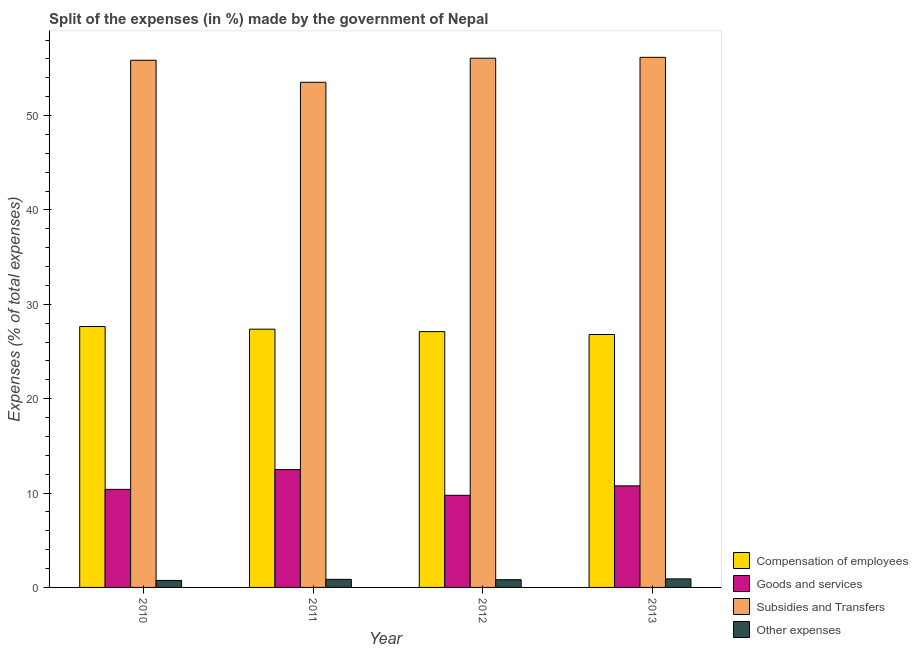Are the number of bars per tick equal to the number of legend labels?
Provide a short and direct response. Yes. Are the number of bars on each tick of the X-axis equal?
Your answer should be compact. Yes. How many bars are there on the 1st tick from the left?
Give a very brief answer. 4. How many bars are there on the 4th tick from the right?
Give a very brief answer. 4. In how many cases, is the number of bars for a given year not equal to the number of legend labels?
Provide a short and direct response. 0. What is the percentage of amount spent on goods and services in 2010?
Provide a short and direct response. 10.39. Across all years, what is the maximum percentage of amount spent on compensation of employees?
Your answer should be compact. 27.65. Across all years, what is the minimum percentage of amount spent on other expenses?
Make the answer very short. 0.74. In which year was the percentage of amount spent on other expenses minimum?
Make the answer very short. 2010. What is the total percentage of amount spent on goods and services in the graph?
Keep it short and to the point. 43.4. What is the difference between the percentage of amount spent on goods and services in 2011 and that in 2012?
Make the answer very short. 2.73. What is the difference between the percentage of amount spent on compensation of employees in 2013 and the percentage of amount spent on subsidies in 2010?
Provide a succinct answer. -0.84. What is the average percentage of amount spent on other expenses per year?
Offer a very short reply. 0.83. In the year 2012, what is the difference between the percentage of amount spent on subsidies and percentage of amount spent on other expenses?
Make the answer very short. 0. What is the ratio of the percentage of amount spent on subsidies in 2011 to that in 2012?
Offer a terse response. 0.95. Is the percentage of amount spent on compensation of employees in 2012 less than that in 2013?
Offer a very short reply. No. Is the difference between the percentage of amount spent on compensation of employees in 2011 and 2013 greater than the difference between the percentage of amount spent on subsidies in 2011 and 2013?
Provide a succinct answer. No. What is the difference between the highest and the second highest percentage of amount spent on subsidies?
Your response must be concise. 0.09. What is the difference between the highest and the lowest percentage of amount spent on subsidies?
Your answer should be very brief. 2.64. Is the sum of the percentage of amount spent on compensation of employees in 2010 and 2013 greater than the maximum percentage of amount spent on other expenses across all years?
Provide a succinct answer. Yes. Is it the case that in every year, the sum of the percentage of amount spent on compensation of employees and percentage of amount spent on other expenses is greater than the sum of percentage of amount spent on subsidies and percentage of amount spent on goods and services?
Keep it short and to the point. No. What does the 2nd bar from the left in 2013 represents?
Offer a very short reply. Goods and services. What does the 2nd bar from the right in 2012 represents?
Your answer should be compact. Subsidies and Transfers. Are all the bars in the graph horizontal?
Ensure brevity in your answer.  No. Are the values on the major ticks of Y-axis written in scientific E-notation?
Offer a terse response. No. Does the graph contain any zero values?
Provide a succinct answer. No. How many legend labels are there?
Give a very brief answer. 4. What is the title of the graph?
Ensure brevity in your answer.  Split of the expenses (in %) made by the government of Nepal. What is the label or title of the X-axis?
Ensure brevity in your answer.  Year. What is the label or title of the Y-axis?
Give a very brief answer. Expenses (% of total expenses). What is the Expenses (% of total expenses) of Compensation of employees in 2010?
Keep it short and to the point. 27.65. What is the Expenses (% of total expenses) in Goods and services in 2010?
Keep it short and to the point. 10.39. What is the Expenses (% of total expenses) of Subsidies and Transfers in 2010?
Ensure brevity in your answer.  55.87. What is the Expenses (% of total expenses) in Other expenses in 2010?
Give a very brief answer. 0.74. What is the Expenses (% of total expenses) in Compensation of employees in 2011?
Your answer should be very brief. 27.37. What is the Expenses (% of total expenses) in Goods and services in 2011?
Provide a succinct answer. 12.49. What is the Expenses (% of total expenses) in Subsidies and Transfers in 2011?
Offer a very short reply. 53.53. What is the Expenses (% of total expenses) of Other expenses in 2011?
Your response must be concise. 0.86. What is the Expenses (% of total expenses) in Compensation of employees in 2012?
Your response must be concise. 27.11. What is the Expenses (% of total expenses) in Goods and services in 2012?
Make the answer very short. 9.76. What is the Expenses (% of total expenses) in Subsidies and Transfers in 2012?
Your response must be concise. 56.08. What is the Expenses (% of total expenses) in Other expenses in 2012?
Ensure brevity in your answer.  0.82. What is the Expenses (% of total expenses) in Compensation of employees in 2013?
Your response must be concise. 26.8. What is the Expenses (% of total expenses) of Goods and services in 2013?
Offer a terse response. 10.76. What is the Expenses (% of total expenses) of Subsidies and Transfers in 2013?
Your response must be concise. 56.17. What is the Expenses (% of total expenses) of Other expenses in 2013?
Give a very brief answer. 0.9. Across all years, what is the maximum Expenses (% of total expenses) in Compensation of employees?
Provide a succinct answer. 27.65. Across all years, what is the maximum Expenses (% of total expenses) of Goods and services?
Your response must be concise. 12.49. Across all years, what is the maximum Expenses (% of total expenses) in Subsidies and Transfers?
Offer a terse response. 56.17. Across all years, what is the maximum Expenses (% of total expenses) in Other expenses?
Provide a succinct answer. 0.9. Across all years, what is the minimum Expenses (% of total expenses) in Compensation of employees?
Your answer should be very brief. 26.8. Across all years, what is the minimum Expenses (% of total expenses) in Goods and services?
Offer a very short reply. 9.76. Across all years, what is the minimum Expenses (% of total expenses) of Subsidies and Transfers?
Make the answer very short. 53.53. Across all years, what is the minimum Expenses (% of total expenses) of Other expenses?
Give a very brief answer. 0.74. What is the total Expenses (% of total expenses) of Compensation of employees in the graph?
Your answer should be compact. 108.92. What is the total Expenses (% of total expenses) of Goods and services in the graph?
Give a very brief answer. 43.4. What is the total Expenses (% of total expenses) in Subsidies and Transfers in the graph?
Keep it short and to the point. 221.65. What is the total Expenses (% of total expenses) of Other expenses in the graph?
Provide a short and direct response. 3.32. What is the difference between the Expenses (% of total expenses) in Compensation of employees in 2010 and that in 2011?
Provide a succinct answer. 0.28. What is the difference between the Expenses (% of total expenses) of Goods and services in 2010 and that in 2011?
Provide a succinct answer. -2.09. What is the difference between the Expenses (% of total expenses) in Subsidies and Transfers in 2010 and that in 2011?
Make the answer very short. 2.33. What is the difference between the Expenses (% of total expenses) in Other expenses in 2010 and that in 2011?
Give a very brief answer. -0.11. What is the difference between the Expenses (% of total expenses) in Compensation of employees in 2010 and that in 2012?
Your response must be concise. 0.54. What is the difference between the Expenses (% of total expenses) of Goods and services in 2010 and that in 2012?
Your response must be concise. 0.63. What is the difference between the Expenses (% of total expenses) of Subsidies and Transfers in 2010 and that in 2012?
Provide a succinct answer. -0.22. What is the difference between the Expenses (% of total expenses) in Other expenses in 2010 and that in 2012?
Offer a very short reply. -0.08. What is the difference between the Expenses (% of total expenses) in Compensation of employees in 2010 and that in 2013?
Your answer should be very brief. 0.84. What is the difference between the Expenses (% of total expenses) of Goods and services in 2010 and that in 2013?
Your answer should be compact. -0.37. What is the difference between the Expenses (% of total expenses) of Subsidies and Transfers in 2010 and that in 2013?
Provide a succinct answer. -0.31. What is the difference between the Expenses (% of total expenses) of Other expenses in 2010 and that in 2013?
Provide a short and direct response. -0.16. What is the difference between the Expenses (% of total expenses) in Compensation of employees in 2011 and that in 2012?
Keep it short and to the point. 0.26. What is the difference between the Expenses (% of total expenses) of Goods and services in 2011 and that in 2012?
Provide a succinct answer. 2.73. What is the difference between the Expenses (% of total expenses) in Subsidies and Transfers in 2011 and that in 2012?
Provide a succinct answer. -2.55. What is the difference between the Expenses (% of total expenses) in Other expenses in 2011 and that in 2012?
Keep it short and to the point. 0.04. What is the difference between the Expenses (% of total expenses) in Compensation of employees in 2011 and that in 2013?
Ensure brevity in your answer.  0.56. What is the difference between the Expenses (% of total expenses) in Goods and services in 2011 and that in 2013?
Provide a succinct answer. 1.72. What is the difference between the Expenses (% of total expenses) of Subsidies and Transfers in 2011 and that in 2013?
Ensure brevity in your answer.  -2.64. What is the difference between the Expenses (% of total expenses) of Other expenses in 2011 and that in 2013?
Make the answer very short. -0.05. What is the difference between the Expenses (% of total expenses) in Compensation of employees in 2012 and that in 2013?
Your answer should be compact. 0.3. What is the difference between the Expenses (% of total expenses) in Goods and services in 2012 and that in 2013?
Provide a short and direct response. -1. What is the difference between the Expenses (% of total expenses) of Subsidies and Transfers in 2012 and that in 2013?
Ensure brevity in your answer.  -0.09. What is the difference between the Expenses (% of total expenses) of Other expenses in 2012 and that in 2013?
Offer a very short reply. -0.08. What is the difference between the Expenses (% of total expenses) of Compensation of employees in 2010 and the Expenses (% of total expenses) of Goods and services in 2011?
Provide a succinct answer. 15.16. What is the difference between the Expenses (% of total expenses) in Compensation of employees in 2010 and the Expenses (% of total expenses) in Subsidies and Transfers in 2011?
Provide a succinct answer. -25.88. What is the difference between the Expenses (% of total expenses) in Compensation of employees in 2010 and the Expenses (% of total expenses) in Other expenses in 2011?
Your answer should be very brief. 26.79. What is the difference between the Expenses (% of total expenses) in Goods and services in 2010 and the Expenses (% of total expenses) in Subsidies and Transfers in 2011?
Ensure brevity in your answer.  -43.14. What is the difference between the Expenses (% of total expenses) in Goods and services in 2010 and the Expenses (% of total expenses) in Other expenses in 2011?
Make the answer very short. 9.54. What is the difference between the Expenses (% of total expenses) of Subsidies and Transfers in 2010 and the Expenses (% of total expenses) of Other expenses in 2011?
Make the answer very short. 55.01. What is the difference between the Expenses (% of total expenses) in Compensation of employees in 2010 and the Expenses (% of total expenses) in Goods and services in 2012?
Give a very brief answer. 17.89. What is the difference between the Expenses (% of total expenses) of Compensation of employees in 2010 and the Expenses (% of total expenses) of Subsidies and Transfers in 2012?
Your response must be concise. -28.43. What is the difference between the Expenses (% of total expenses) of Compensation of employees in 2010 and the Expenses (% of total expenses) of Other expenses in 2012?
Keep it short and to the point. 26.83. What is the difference between the Expenses (% of total expenses) in Goods and services in 2010 and the Expenses (% of total expenses) in Subsidies and Transfers in 2012?
Offer a terse response. -45.69. What is the difference between the Expenses (% of total expenses) in Goods and services in 2010 and the Expenses (% of total expenses) in Other expenses in 2012?
Provide a short and direct response. 9.57. What is the difference between the Expenses (% of total expenses) in Subsidies and Transfers in 2010 and the Expenses (% of total expenses) in Other expenses in 2012?
Offer a terse response. 55.05. What is the difference between the Expenses (% of total expenses) in Compensation of employees in 2010 and the Expenses (% of total expenses) in Goods and services in 2013?
Provide a succinct answer. 16.88. What is the difference between the Expenses (% of total expenses) of Compensation of employees in 2010 and the Expenses (% of total expenses) of Subsidies and Transfers in 2013?
Make the answer very short. -28.53. What is the difference between the Expenses (% of total expenses) in Compensation of employees in 2010 and the Expenses (% of total expenses) in Other expenses in 2013?
Make the answer very short. 26.74. What is the difference between the Expenses (% of total expenses) of Goods and services in 2010 and the Expenses (% of total expenses) of Subsidies and Transfers in 2013?
Your response must be concise. -45.78. What is the difference between the Expenses (% of total expenses) of Goods and services in 2010 and the Expenses (% of total expenses) of Other expenses in 2013?
Offer a very short reply. 9.49. What is the difference between the Expenses (% of total expenses) of Subsidies and Transfers in 2010 and the Expenses (% of total expenses) of Other expenses in 2013?
Offer a terse response. 54.96. What is the difference between the Expenses (% of total expenses) of Compensation of employees in 2011 and the Expenses (% of total expenses) of Goods and services in 2012?
Ensure brevity in your answer.  17.61. What is the difference between the Expenses (% of total expenses) in Compensation of employees in 2011 and the Expenses (% of total expenses) in Subsidies and Transfers in 2012?
Your answer should be very brief. -28.72. What is the difference between the Expenses (% of total expenses) of Compensation of employees in 2011 and the Expenses (% of total expenses) of Other expenses in 2012?
Offer a very short reply. 26.55. What is the difference between the Expenses (% of total expenses) in Goods and services in 2011 and the Expenses (% of total expenses) in Subsidies and Transfers in 2012?
Your answer should be very brief. -43.6. What is the difference between the Expenses (% of total expenses) of Goods and services in 2011 and the Expenses (% of total expenses) of Other expenses in 2012?
Keep it short and to the point. 11.66. What is the difference between the Expenses (% of total expenses) in Subsidies and Transfers in 2011 and the Expenses (% of total expenses) in Other expenses in 2012?
Give a very brief answer. 52.71. What is the difference between the Expenses (% of total expenses) of Compensation of employees in 2011 and the Expenses (% of total expenses) of Goods and services in 2013?
Offer a terse response. 16.6. What is the difference between the Expenses (% of total expenses) in Compensation of employees in 2011 and the Expenses (% of total expenses) in Subsidies and Transfers in 2013?
Your answer should be very brief. -28.81. What is the difference between the Expenses (% of total expenses) of Compensation of employees in 2011 and the Expenses (% of total expenses) of Other expenses in 2013?
Your answer should be very brief. 26.46. What is the difference between the Expenses (% of total expenses) of Goods and services in 2011 and the Expenses (% of total expenses) of Subsidies and Transfers in 2013?
Your response must be concise. -43.69. What is the difference between the Expenses (% of total expenses) of Goods and services in 2011 and the Expenses (% of total expenses) of Other expenses in 2013?
Offer a terse response. 11.58. What is the difference between the Expenses (% of total expenses) of Subsidies and Transfers in 2011 and the Expenses (% of total expenses) of Other expenses in 2013?
Provide a succinct answer. 52.63. What is the difference between the Expenses (% of total expenses) in Compensation of employees in 2012 and the Expenses (% of total expenses) in Goods and services in 2013?
Offer a very short reply. 16.34. What is the difference between the Expenses (% of total expenses) in Compensation of employees in 2012 and the Expenses (% of total expenses) in Subsidies and Transfers in 2013?
Give a very brief answer. -29.07. What is the difference between the Expenses (% of total expenses) of Compensation of employees in 2012 and the Expenses (% of total expenses) of Other expenses in 2013?
Offer a terse response. 26.2. What is the difference between the Expenses (% of total expenses) of Goods and services in 2012 and the Expenses (% of total expenses) of Subsidies and Transfers in 2013?
Offer a terse response. -46.41. What is the difference between the Expenses (% of total expenses) of Goods and services in 2012 and the Expenses (% of total expenses) of Other expenses in 2013?
Keep it short and to the point. 8.86. What is the difference between the Expenses (% of total expenses) of Subsidies and Transfers in 2012 and the Expenses (% of total expenses) of Other expenses in 2013?
Provide a succinct answer. 55.18. What is the average Expenses (% of total expenses) in Compensation of employees per year?
Give a very brief answer. 27.23. What is the average Expenses (% of total expenses) in Goods and services per year?
Your answer should be very brief. 10.85. What is the average Expenses (% of total expenses) in Subsidies and Transfers per year?
Your response must be concise. 55.41. What is the average Expenses (% of total expenses) in Other expenses per year?
Your answer should be compact. 0.83. In the year 2010, what is the difference between the Expenses (% of total expenses) of Compensation of employees and Expenses (% of total expenses) of Goods and services?
Offer a terse response. 17.26. In the year 2010, what is the difference between the Expenses (% of total expenses) in Compensation of employees and Expenses (% of total expenses) in Subsidies and Transfers?
Your answer should be very brief. -28.22. In the year 2010, what is the difference between the Expenses (% of total expenses) of Compensation of employees and Expenses (% of total expenses) of Other expenses?
Make the answer very short. 26.91. In the year 2010, what is the difference between the Expenses (% of total expenses) in Goods and services and Expenses (% of total expenses) in Subsidies and Transfers?
Give a very brief answer. -45.47. In the year 2010, what is the difference between the Expenses (% of total expenses) in Goods and services and Expenses (% of total expenses) in Other expenses?
Provide a short and direct response. 9.65. In the year 2010, what is the difference between the Expenses (% of total expenses) of Subsidies and Transfers and Expenses (% of total expenses) of Other expenses?
Provide a short and direct response. 55.12. In the year 2011, what is the difference between the Expenses (% of total expenses) in Compensation of employees and Expenses (% of total expenses) in Goods and services?
Give a very brief answer. 14.88. In the year 2011, what is the difference between the Expenses (% of total expenses) in Compensation of employees and Expenses (% of total expenses) in Subsidies and Transfers?
Offer a very short reply. -26.17. In the year 2011, what is the difference between the Expenses (% of total expenses) in Compensation of employees and Expenses (% of total expenses) in Other expenses?
Ensure brevity in your answer.  26.51. In the year 2011, what is the difference between the Expenses (% of total expenses) of Goods and services and Expenses (% of total expenses) of Subsidies and Transfers?
Ensure brevity in your answer.  -41.05. In the year 2011, what is the difference between the Expenses (% of total expenses) in Goods and services and Expenses (% of total expenses) in Other expenses?
Your answer should be very brief. 11.63. In the year 2011, what is the difference between the Expenses (% of total expenses) in Subsidies and Transfers and Expenses (% of total expenses) in Other expenses?
Your answer should be very brief. 52.68. In the year 2012, what is the difference between the Expenses (% of total expenses) of Compensation of employees and Expenses (% of total expenses) of Goods and services?
Your answer should be very brief. 17.35. In the year 2012, what is the difference between the Expenses (% of total expenses) of Compensation of employees and Expenses (% of total expenses) of Subsidies and Transfers?
Keep it short and to the point. -28.97. In the year 2012, what is the difference between the Expenses (% of total expenses) in Compensation of employees and Expenses (% of total expenses) in Other expenses?
Your response must be concise. 26.29. In the year 2012, what is the difference between the Expenses (% of total expenses) in Goods and services and Expenses (% of total expenses) in Subsidies and Transfers?
Offer a terse response. -46.32. In the year 2012, what is the difference between the Expenses (% of total expenses) in Goods and services and Expenses (% of total expenses) in Other expenses?
Your answer should be very brief. 8.94. In the year 2012, what is the difference between the Expenses (% of total expenses) in Subsidies and Transfers and Expenses (% of total expenses) in Other expenses?
Offer a very short reply. 55.26. In the year 2013, what is the difference between the Expenses (% of total expenses) in Compensation of employees and Expenses (% of total expenses) in Goods and services?
Provide a short and direct response. 16.04. In the year 2013, what is the difference between the Expenses (% of total expenses) in Compensation of employees and Expenses (% of total expenses) in Subsidies and Transfers?
Provide a short and direct response. -29.37. In the year 2013, what is the difference between the Expenses (% of total expenses) in Compensation of employees and Expenses (% of total expenses) in Other expenses?
Offer a very short reply. 25.9. In the year 2013, what is the difference between the Expenses (% of total expenses) of Goods and services and Expenses (% of total expenses) of Subsidies and Transfers?
Ensure brevity in your answer.  -45.41. In the year 2013, what is the difference between the Expenses (% of total expenses) in Goods and services and Expenses (% of total expenses) in Other expenses?
Offer a terse response. 9.86. In the year 2013, what is the difference between the Expenses (% of total expenses) in Subsidies and Transfers and Expenses (% of total expenses) in Other expenses?
Provide a succinct answer. 55.27. What is the ratio of the Expenses (% of total expenses) in Compensation of employees in 2010 to that in 2011?
Keep it short and to the point. 1.01. What is the ratio of the Expenses (% of total expenses) in Goods and services in 2010 to that in 2011?
Ensure brevity in your answer.  0.83. What is the ratio of the Expenses (% of total expenses) in Subsidies and Transfers in 2010 to that in 2011?
Your answer should be compact. 1.04. What is the ratio of the Expenses (% of total expenses) of Other expenses in 2010 to that in 2011?
Ensure brevity in your answer.  0.87. What is the ratio of the Expenses (% of total expenses) in Compensation of employees in 2010 to that in 2012?
Offer a terse response. 1.02. What is the ratio of the Expenses (% of total expenses) in Goods and services in 2010 to that in 2012?
Offer a very short reply. 1.06. What is the ratio of the Expenses (% of total expenses) of Other expenses in 2010 to that in 2012?
Provide a succinct answer. 0.9. What is the ratio of the Expenses (% of total expenses) of Compensation of employees in 2010 to that in 2013?
Provide a succinct answer. 1.03. What is the ratio of the Expenses (% of total expenses) of Goods and services in 2010 to that in 2013?
Keep it short and to the point. 0.97. What is the ratio of the Expenses (% of total expenses) of Subsidies and Transfers in 2010 to that in 2013?
Your response must be concise. 0.99. What is the ratio of the Expenses (% of total expenses) of Other expenses in 2010 to that in 2013?
Your response must be concise. 0.82. What is the ratio of the Expenses (% of total expenses) of Compensation of employees in 2011 to that in 2012?
Keep it short and to the point. 1.01. What is the ratio of the Expenses (% of total expenses) in Goods and services in 2011 to that in 2012?
Provide a succinct answer. 1.28. What is the ratio of the Expenses (% of total expenses) of Subsidies and Transfers in 2011 to that in 2012?
Make the answer very short. 0.95. What is the ratio of the Expenses (% of total expenses) of Other expenses in 2011 to that in 2012?
Provide a short and direct response. 1.04. What is the ratio of the Expenses (% of total expenses) of Goods and services in 2011 to that in 2013?
Make the answer very short. 1.16. What is the ratio of the Expenses (% of total expenses) in Subsidies and Transfers in 2011 to that in 2013?
Offer a very short reply. 0.95. What is the ratio of the Expenses (% of total expenses) in Other expenses in 2011 to that in 2013?
Your answer should be compact. 0.95. What is the ratio of the Expenses (% of total expenses) of Compensation of employees in 2012 to that in 2013?
Keep it short and to the point. 1.01. What is the ratio of the Expenses (% of total expenses) in Goods and services in 2012 to that in 2013?
Offer a terse response. 0.91. What is the ratio of the Expenses (% of total expenses) in Other expenses in 2012 to that in 2013?
Your answer should be very brief. 0.91. What is the difference between the highest and the second highest Expenses (% of total expenses) in Compensation of employees?
Your answer should be very brief. 0.28. What is the difference between the highest and the second highest Expenses (% of total expenses) in Goods and services?
Offer a terse response. 1.72. What is the difference between the highest and the second highest Expenses (% of total expenses) of Subsidies and Transfers?
Give a very brief answer. 0.09. What is the difference between the highest and the second highest Expenses (% of total expenses) in Other expenses?
Your response must be concise. 0.05. What is the difference between the highest and the lowest Expenses (% of total expenses) in Compensation of employees?
Your response must be concise. 0.84. What is the difference between the highest and the lowest Expenses (% of total expenses) in Goods and services?
Give a very brief answer. 2.73. What is the difference between the highest and the lowest Expenses (% of total expenses) in Subsidies and Transfers?
Give a very brief answer. 2.64. What is the difference between the highest and the lowest Expenses (% of total expenses) in Other expenses?
Make the answer very short. 0.16. 